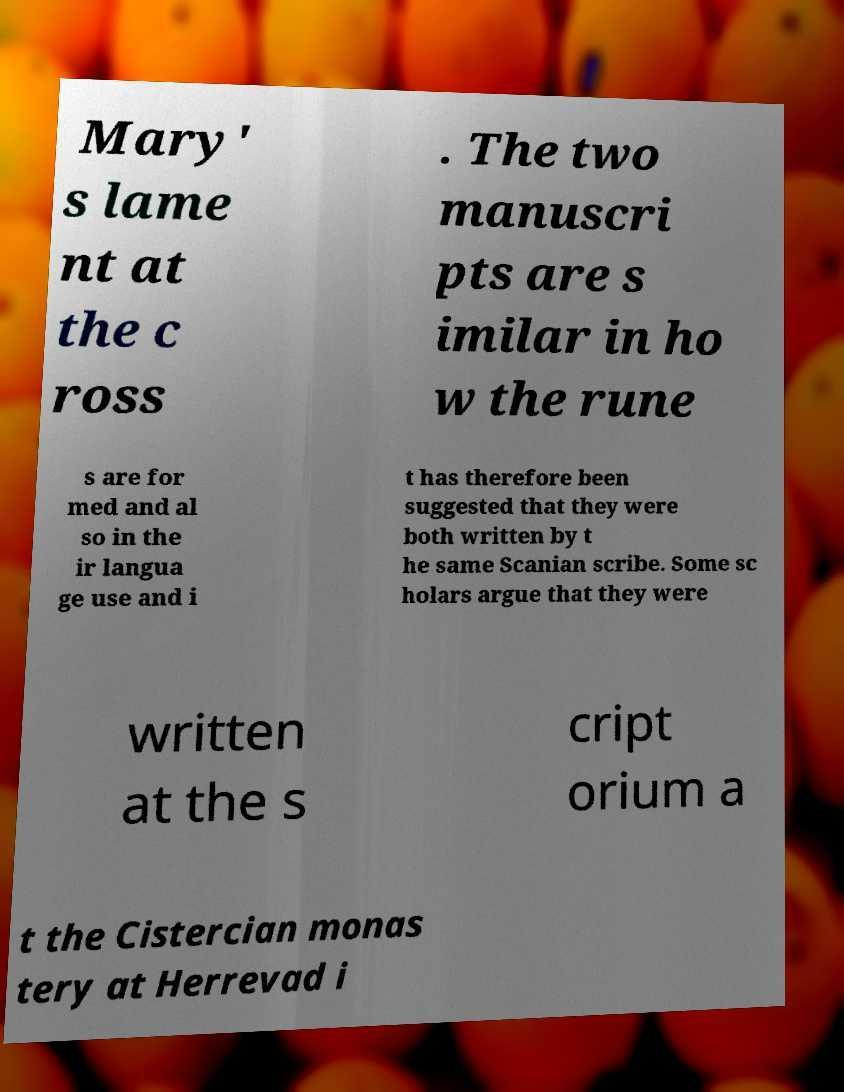Could you extract and type out the text from this image? Mary' s lame nt at the c ross . The two manuscri pts are s imilar in ho w the rune s are for med and al so in the ir langua ge use and i t has therefore been suggested that they were both written by t he same Scanian scribe. Some sc holars argue that they were written at the s cript orium a t the Cistercian monas tery at Herrevad i 